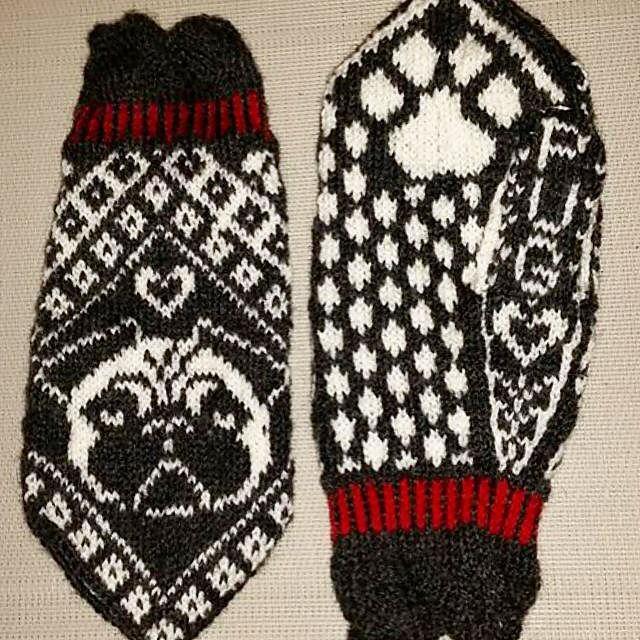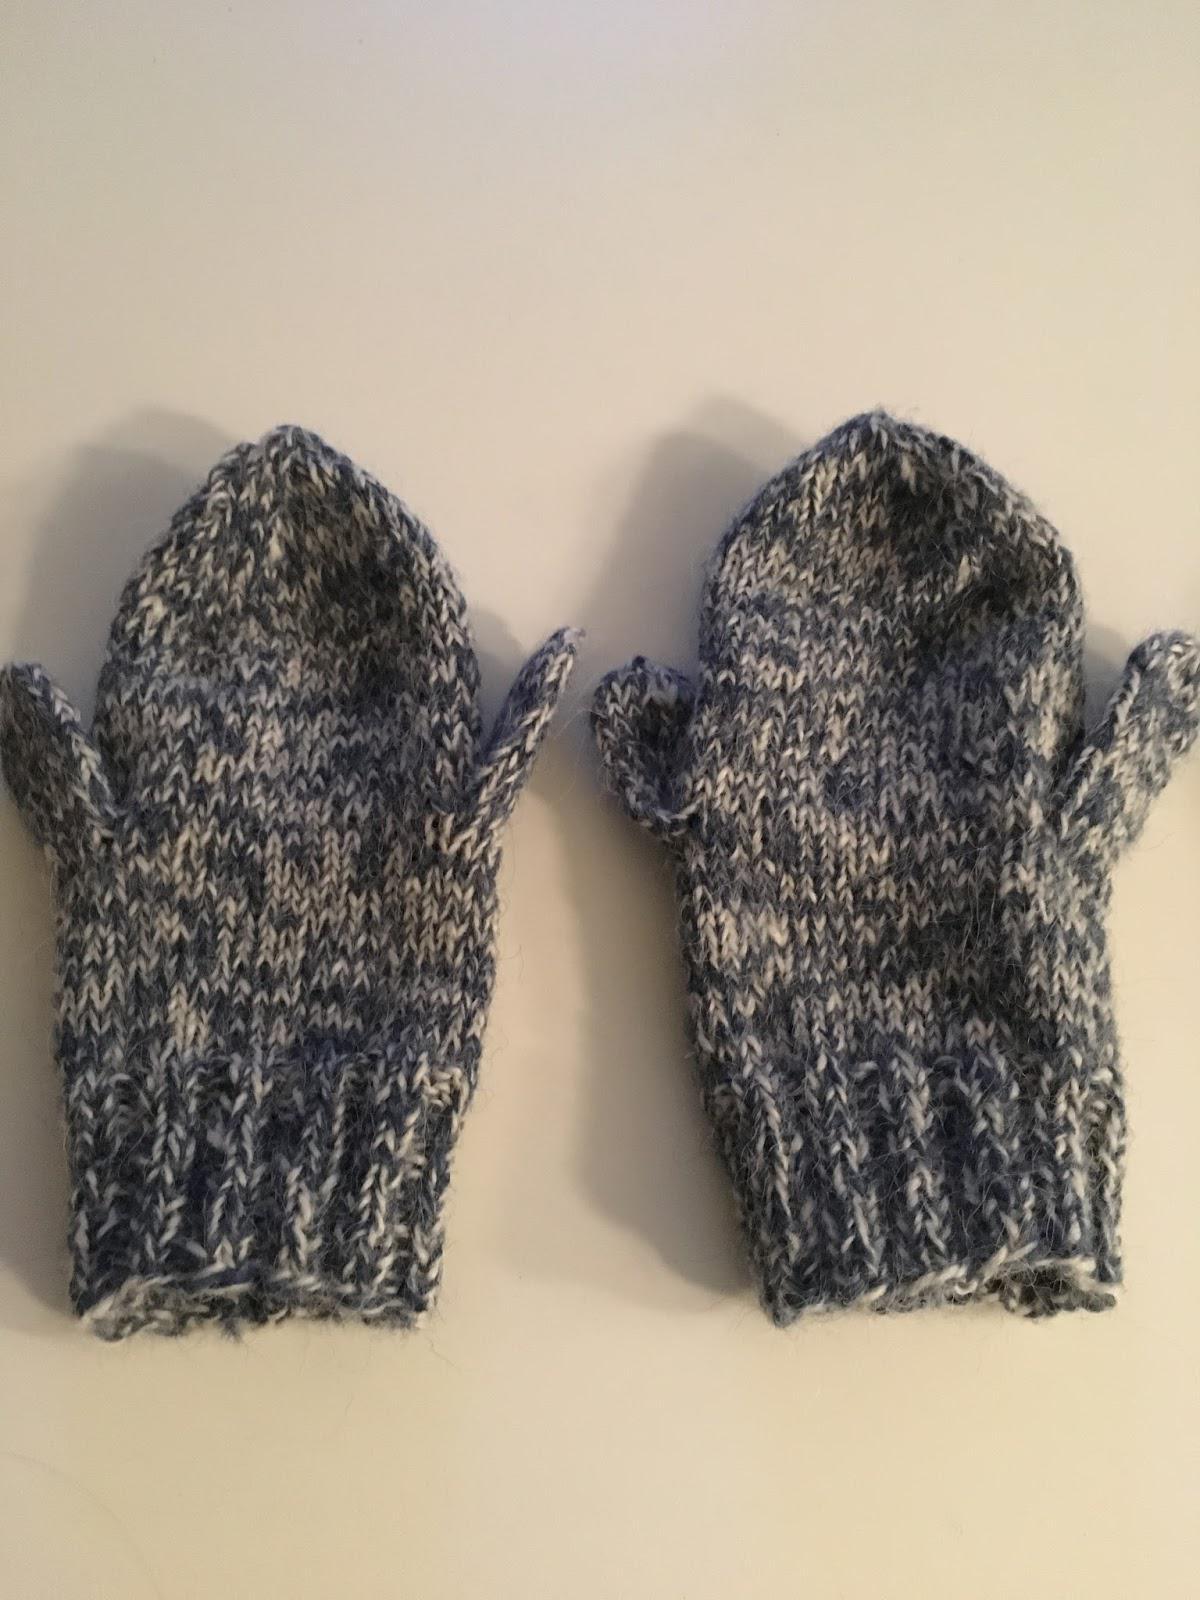The first image is the image on the left, the second image is the image on the right. Assess this claim about the two images: "The left and right image contains the same number of mittens with at least one set green.". Correct or not? Answer yes or no. No. The first image is the image on the left, the second image is the image on the right. Examine the images to the left and right. Is the description "Each image contains a pair of mittens, and one pair of mittens has an animal figure on the front-facing mitten." accurate? Answer yes or no. Yes. 